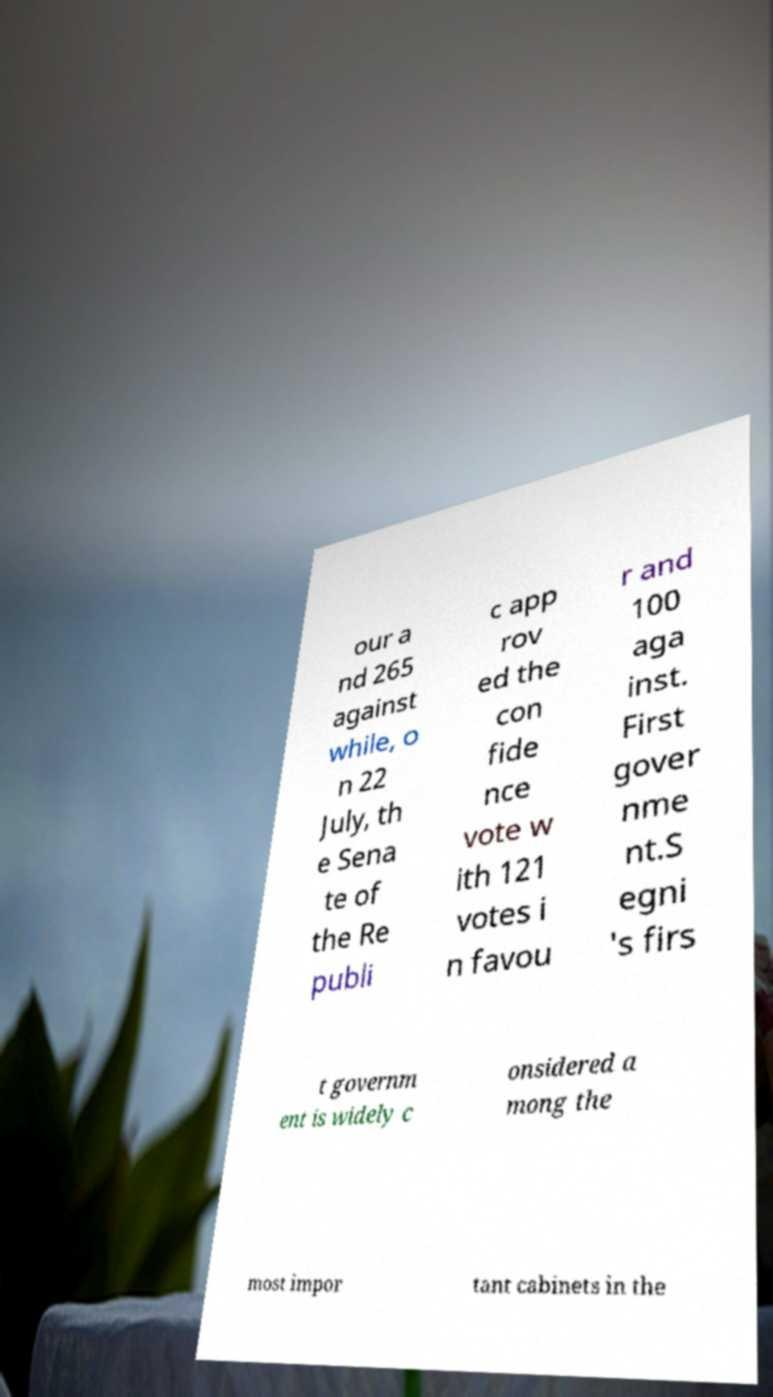There's text embedded in this image that I need extracted. Can you transcribe it verbatim? our a nd 265 against while, o n 22 July, th e Sena te of the Re publi c app rov ed the con fide nce vote w ith 121 votes i n favou r and 100 aga inst. First gover nme nt.S egni 's firs t governm ent is widely c onsidered a mong the most impor tant cabinets in the 